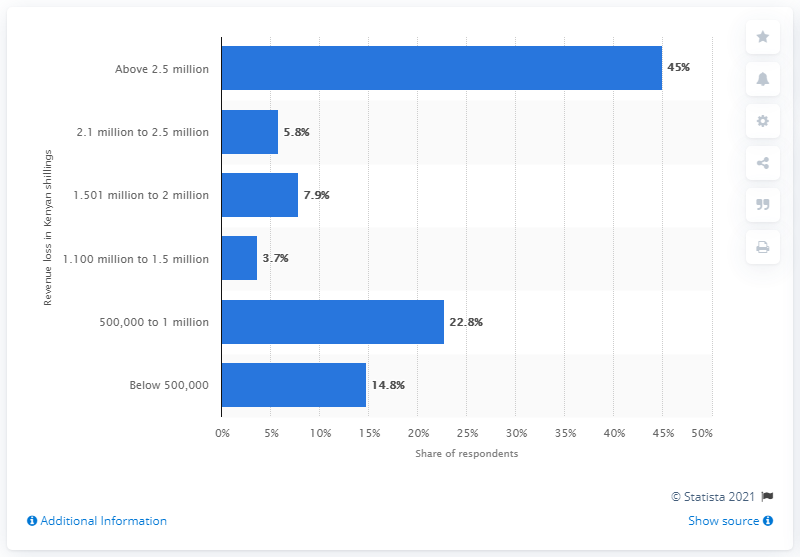Mention a couple of crucial points in this snapshot. According to an estimate by tourism businesses in Kenya, 45% of them have suffered a revenue loss of above 2.5 million shillings in the first half of 2020 due to the COVID-19 pandemic. According to a recent survey of tourism businesses in Kenya, 22.8% reported a loss of between 500,000 and 1,000,000 Kenyan Shillings. 